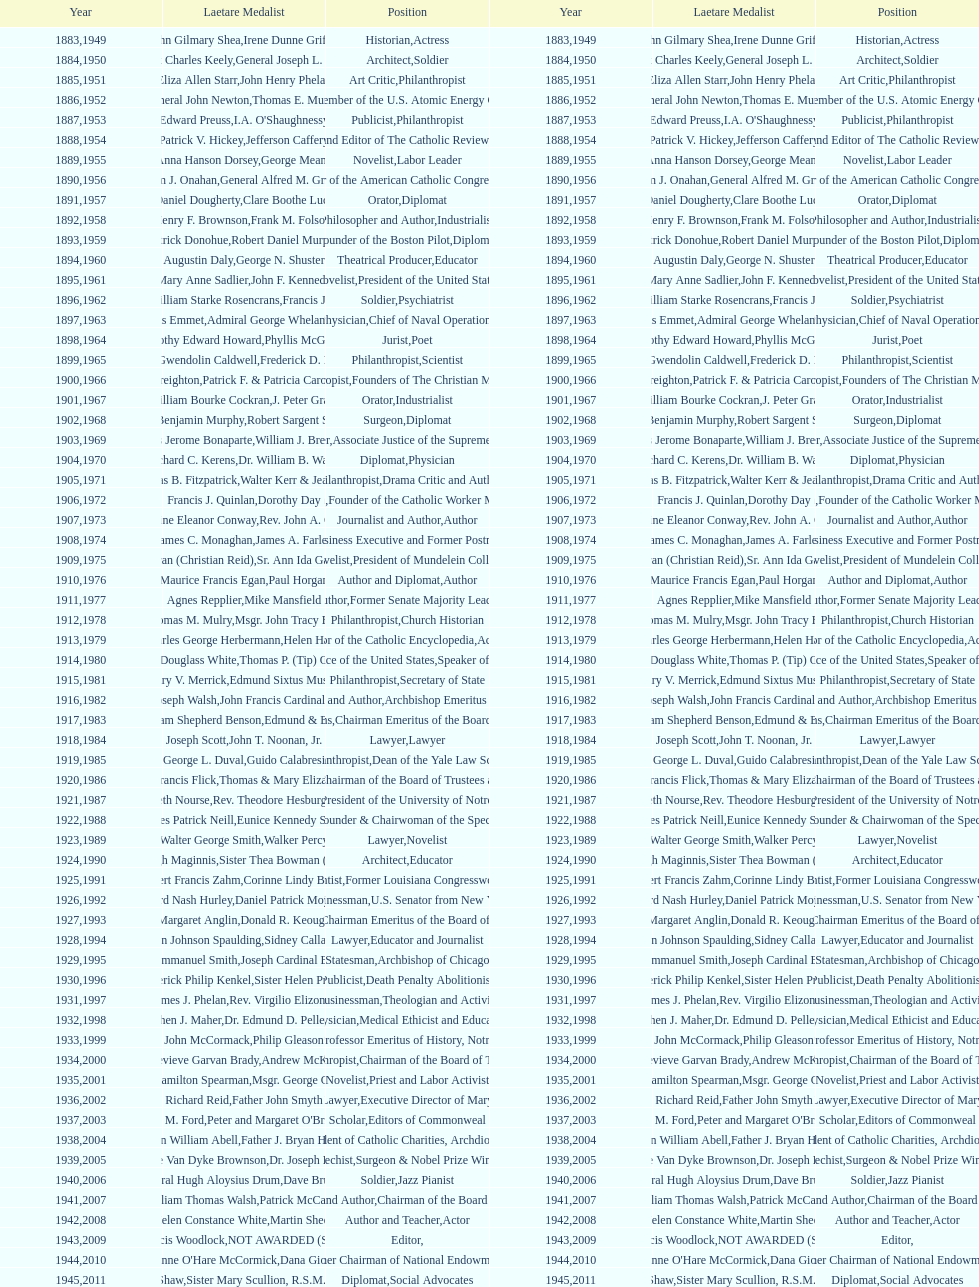How many laetare medalists were philantrohpists? 2. Can you give me this table as a dict? {'header': ['Year', 'Laetare Medalist', 'Position', 'Year', 'Laetare Medalist', 'Position'], 'rows': [['1883', 'John Gilmary Shea', 'Historian', '1949', 'Irene Dunne Griffin', 'Actress'], ['1884', 'Patrick Charles Keely', 'Architect', '1950', 'General Joseph L. Collins', 'Soldier'], ['1885', 'Eliza Allen Starr', 'Art Critic', '1951', 'John Henry Phelan', 'Philanthropist'], ['1886', 'General John Newton', 'Engineer', '1952', 'Thomas E. Murray', 'Member of the U.S. Atomic Energy Commission'], ['1887', 'Edward Preuss', 'Publicist', '1953', "I.A. O'Shaughnessy", 'Philanthropist'], ['1888', 'Patrick V. Hickey', 'Founder and Editor of The Catholic Review', '1954', 'Jefferson Caffery', 'Diplomat'], ['1889', 'Anna Hanson Dorsey', 'Novelist', '1955', 'George Meany', 'Labor Leader'], ['1890', 'William J. Onahan', 'Organizer of the American Catholic Congress', '1956', 'General Alfred M. Gruenther', 'Soldier'], ['1891', 'Daniel Dougherty', 'Orator', '1957', 'Clare Boothe Luce', 'Diplomat'], ['1892', 'Henry F. Brownson', 'Philosopher and Author', '1958', 'Frank M. Folsom', 'Industrialist'], ['1893', 'Patrick Donohue', 'Founder of the Boston Pilot', '1959', 'Robert Daniel Murphy', 'Diplomat'], ['1894', 'Augustin Daly', 'Theatrical Producer', '1960', 'George N. Shuster', 'Educator'], ['1895', 'Mary Anne Sadlier', 'Novelist', '1961', 'John F. Kennedy', 'President of the United States'], ['1896', 'General William Starke Rosencrans', 'Soldier', '1962', 'Francis J. Braceland', 'Psychiatrist'], ['1897', 'Thomas Addis Emmet', 'Physician', '1963', 'Admiral George Whelan Anderson, Jr.', 'Chief of Naval Operations'], ['1898', 'Timothy Edward Howard', 'Jurist', '1964', 'Phyllis McGinley', 'Poet'], ['1899', 'Mary Gwendolin Caldwell', 'Philanthropist', '1965', 'Frederick D. Rossini', 'Scientist'], ['1900', 'John A. Creighton', 'Philanthropist', '1966', 'Patrick F. & Patricia Caron Crowley', 'Founders of The Christian Movement'], ['1901', 'William Bourke Cockran', 'Orator', '1967', 'J. Peter Grace', 'Industrialist'], ['1902', 'John Benjamin Murphy', 'Surgeon', '1968', 'Robert Sargent Shriver', 'Diplomat'], ['1903', 'Charles Jerome Bonaparte', 'Lawyer', '1969', 'William J. Brennan Jr.', 'Associate Justice of the Supreme Court'], ['1904', 'Richard C. Kerens', 'Diplomat', '1970', 'Dr. William B. Walsh', 'Physician'], ['1905', 'Thomas B. Fitzpatrick', 'Philanthropist', '1971', 'Walter Kerr & Jean Kerr', 'Drama Critic and Author'], ['1906', 'Francis J. Quinlan', 'Physician', '1972', 'Dorothy Day', 'Founder of the Catholic Worker Movement'], ['1907', 'Katherine Eleanor Conway', 'Journalist and Author', '1973', "Rev. John A. O'Brien", 'Author'], ['1908', 'James C. Monaghan', 'Economist', '1974', 'James A. Farley', 'Business Executive and Former Postmaster General'], ['1909', 'Frances Tieran (Christian Reid)', 'Novelist', '1975', 'Sr. Ann Ida Gannon, BMV', 'President of Mundelein College'], ['1910', 'Maurice Francis Egan', 'Author and Diplomat', '1976', 'Paul Horgan', 'Author'], ['1911', 'Agnes Repplier', 'Author', '1977', 'Mike Mansfield', 'Former Senate Majority Leader'], ['1912', 'Thomas M. Mulry', 'Philanthropist', '1978', 'Msgr. John Tracy Ellis', 'Church Historian'], ['1913', 'Charles George Herbermann', 'Editor of the Catholic Encyclopedia', '1979', 'Helen Hayes', 'Actress'], ['1914', 'Edward Douglass White', 'Chief Justice of the United States', '1980', "Thomas P. (Tip) O'Neill Jr.", 'Speaker of the House'], ['1915', 'Mary V. Merrick', 'Philanthropist', '1981', 'Edmund Sixtus Muskie', 'Secretary of State'], ['1916', 'James Joseph Walsh', 'Physician and Author', '1982', 'John Francis Cardinal Dearden', 'Archbishop Emeritus of Detroit'], ['1917', 'Admiral William Shepherd Benson', 'Chief of Naval Operations', '1983', 'Edmund & Evelyn Stephan', 'Chairman Emeritus of the Board of Trustees and his wife'], ['1918', 'Joseph Scott', 'Lawyer', '1984', 'John T. Noonan, Jr.', 'Lawyer'], ['1919', 'George L. Duval', 'Philanthropist', '1985', 'Guido Calabresi', 'Dean of the Yale Law School'], ['1920', 'Lawrence Francis Flick', 'Physician', '1986', 'Thomas & Mary Elizabeth Carney', 'Chairman of the Board of Trustees and his wife'], ['1921', 'Elizabeth Nourse', 'Artist', '1987', 'Rev. Theodore Hesburgh, CSC', 'President of the University of Notre Dame'], ['1922', 'Charles Patrick Neill', 'Economist', '1988', 'Eunice Kennedy Shriver', 'Founder & Chairwoman of the Special Olympics'], ['1923', 'Walter George Smith', 'Lawyer', '1989', 'Walker Percy', 'Novelist'], ['1924', 'Charles Donagh Maginnis', 'Architect', '1990', 'Sister Thea Bowman (posthumously)', 'Educator'], ['1925', 'Albert Francis Zahm', 'Scientist', '1991', 'Corinne Lindy Boggs', 'Former Louisiana Congresswoman'], ['1926', 'Edward Nash Hurley', 'Businessman', '1992', 'Daniel Patrick Moynihan', 'U.S. Senator from New York'], ['1927', 'Margaret Anglin', 'Actress', '1993', 'Donald R. Keough', 'Chairman Emeritus of the Board of Trustees'], ['1928', 'John Johnson Spaulding', 'Lawyer', '1994', 'Sidney Callahan', 'Educator and Journalist'], ['1929', 'Alfred Emmanuel Smith', 'Statesman', '1995', 'Joseph Cardinal Bernardin', 'Archbishop of Chicago'], ['1930', 'Frederick Philip Kenkel', 'Publicist', '1996', 'Sister Helen Prejean', 'Death Penalty Abolitionist'], ['1931', 'James J. Phelan', 'Businessman', '1997', 'Rev. Virgilio Elizondo', 'Theologian and Activist'], ['1932', 'Stephen J. Maher', 'Physician', '1998', 'Dr. Edmund D. Pellegrino', 'Medical Ethicist and Educator'], ['1933', 'John McCormack', 'Artist', '1999', 'Philip Gleason', 'Professor Emeritus of History, Notre Dame'], ['1934', 'Genevieve Garvan Brady', 'Philanthropist', '2000', 'Andrew McKenna', 'Chairman of the Board of Trustees'], ['1935', 'Francis Hamilton Spearman', 'Novelist', '2001', 'Msgr. George G. Higgins', 'Priest and Labor Activist'], ['1936', 'Richard Reid', 'Journalist and Lawyer', '2002', 'Father John Smyth', 'Executive Director of Maryville Academy'], ['1937', 'Jeremiah D. M. Ford', 'Scholar', '2003', "Peter and Margaret O'Brien Steinfels", 'Editors of Commonweal'], ['1938', 'Irvin William Abell', 'Surgeon', '2004', 'Father J. Bryan Hehir', 'President of Catholic Charities, Archdiocese of Boston'], ['1939', 'Josephine Van Dyke Brownson', 'Catechist', '2005', 'Dr. Joseph E. Murray', 'Surgeon & Nobel Prize Winner'], ['1940', 'General Hugh Aloysius Drum', 'Soldier', '2006', 'Dave Brubeck', 'Jazz Pianist'], ['1941', 'William Thomas Walsh', 'Journalist and Author', '2007', 'Patrick McCartan', 'Chairman of the Board of Trustees'], ['1942', 'Helen Constance White', 'Author and Teacher', '2008', 'Martin Sheen', 'Actor'], ['1943', 'Thomas Francis Woodlock', 'Editor', '2009', 'NOT AWARDED (SEE BELOW)', ''], ['1944', "Anne O'Hare McCormick", 'Journalist', '2010', 'Dana Gioia', 'Former Chairman of National Endowment for the Arts'], ['1945', 'Gardiner Howland Shaw', 'Diplomat', '2011', 'Sister Mary Scullion, R.S.M., & Joan McConnon', 'Social Advocates'], ['1946', 'Carlton J. H. Hayes', 'Historian and Diplomat', '2012', 'Ken Hackett', 'Former President of Catholic Relief Services'], ['1947', 'William G. Bruce', 'Publisher and Civic Leader', '2013', 'Sister Susanne Gallagher, S.P.\\nSister Mary Therese Harrington, S.H.\\nRev. James H. McCarthy', 'Founders of S.P.R.E.D. (Special Religious Education Development Network)'], ['1948', 'Frank C. Walker', 'Postmaster General and Civic Leader', '2014', 'Kenneth R. Miller', 'Professor of Biology at Brown University']]} 